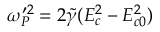Convert formula to latex. <formula><loc_0><loc_0><loc_500><loc_500>{ \omega } _ { P } ^ { \prime 2 } = 2 \tilde { \gamma } ( E _ { c } ^ { 2 } - E _ { c 0 } ^ { 2 } )</formula> 